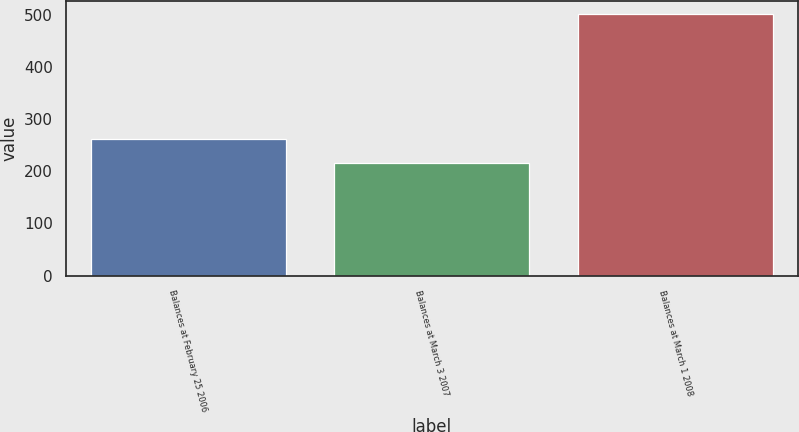Convert chart to OTSL. <chart><loc_0><loc_0><loc_500><loc_500><bar_chart><fcel>Balances at February 25 2006<fcel>Balances at March 3 2007<fcel>Balances at March 1 2008<nl><fcel>261<fcel>216<fcel>502<nl></chart> 